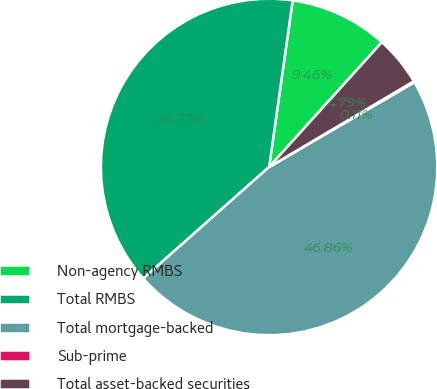Convert chart. <chart><loc_0><loc_0><loc_500><loc_500><pie_chart><fcel>Non-agency RMBS<fcel>Total RMBS<fcel>Total mortgage-backed<fcel>Sub-prime<fcel>Total asset-backed securities<nl><fcel>9.46%<fcel>38.77%<fcel>46.86%<fcel>0.11%<fcel>4.79%<nl></chart> 